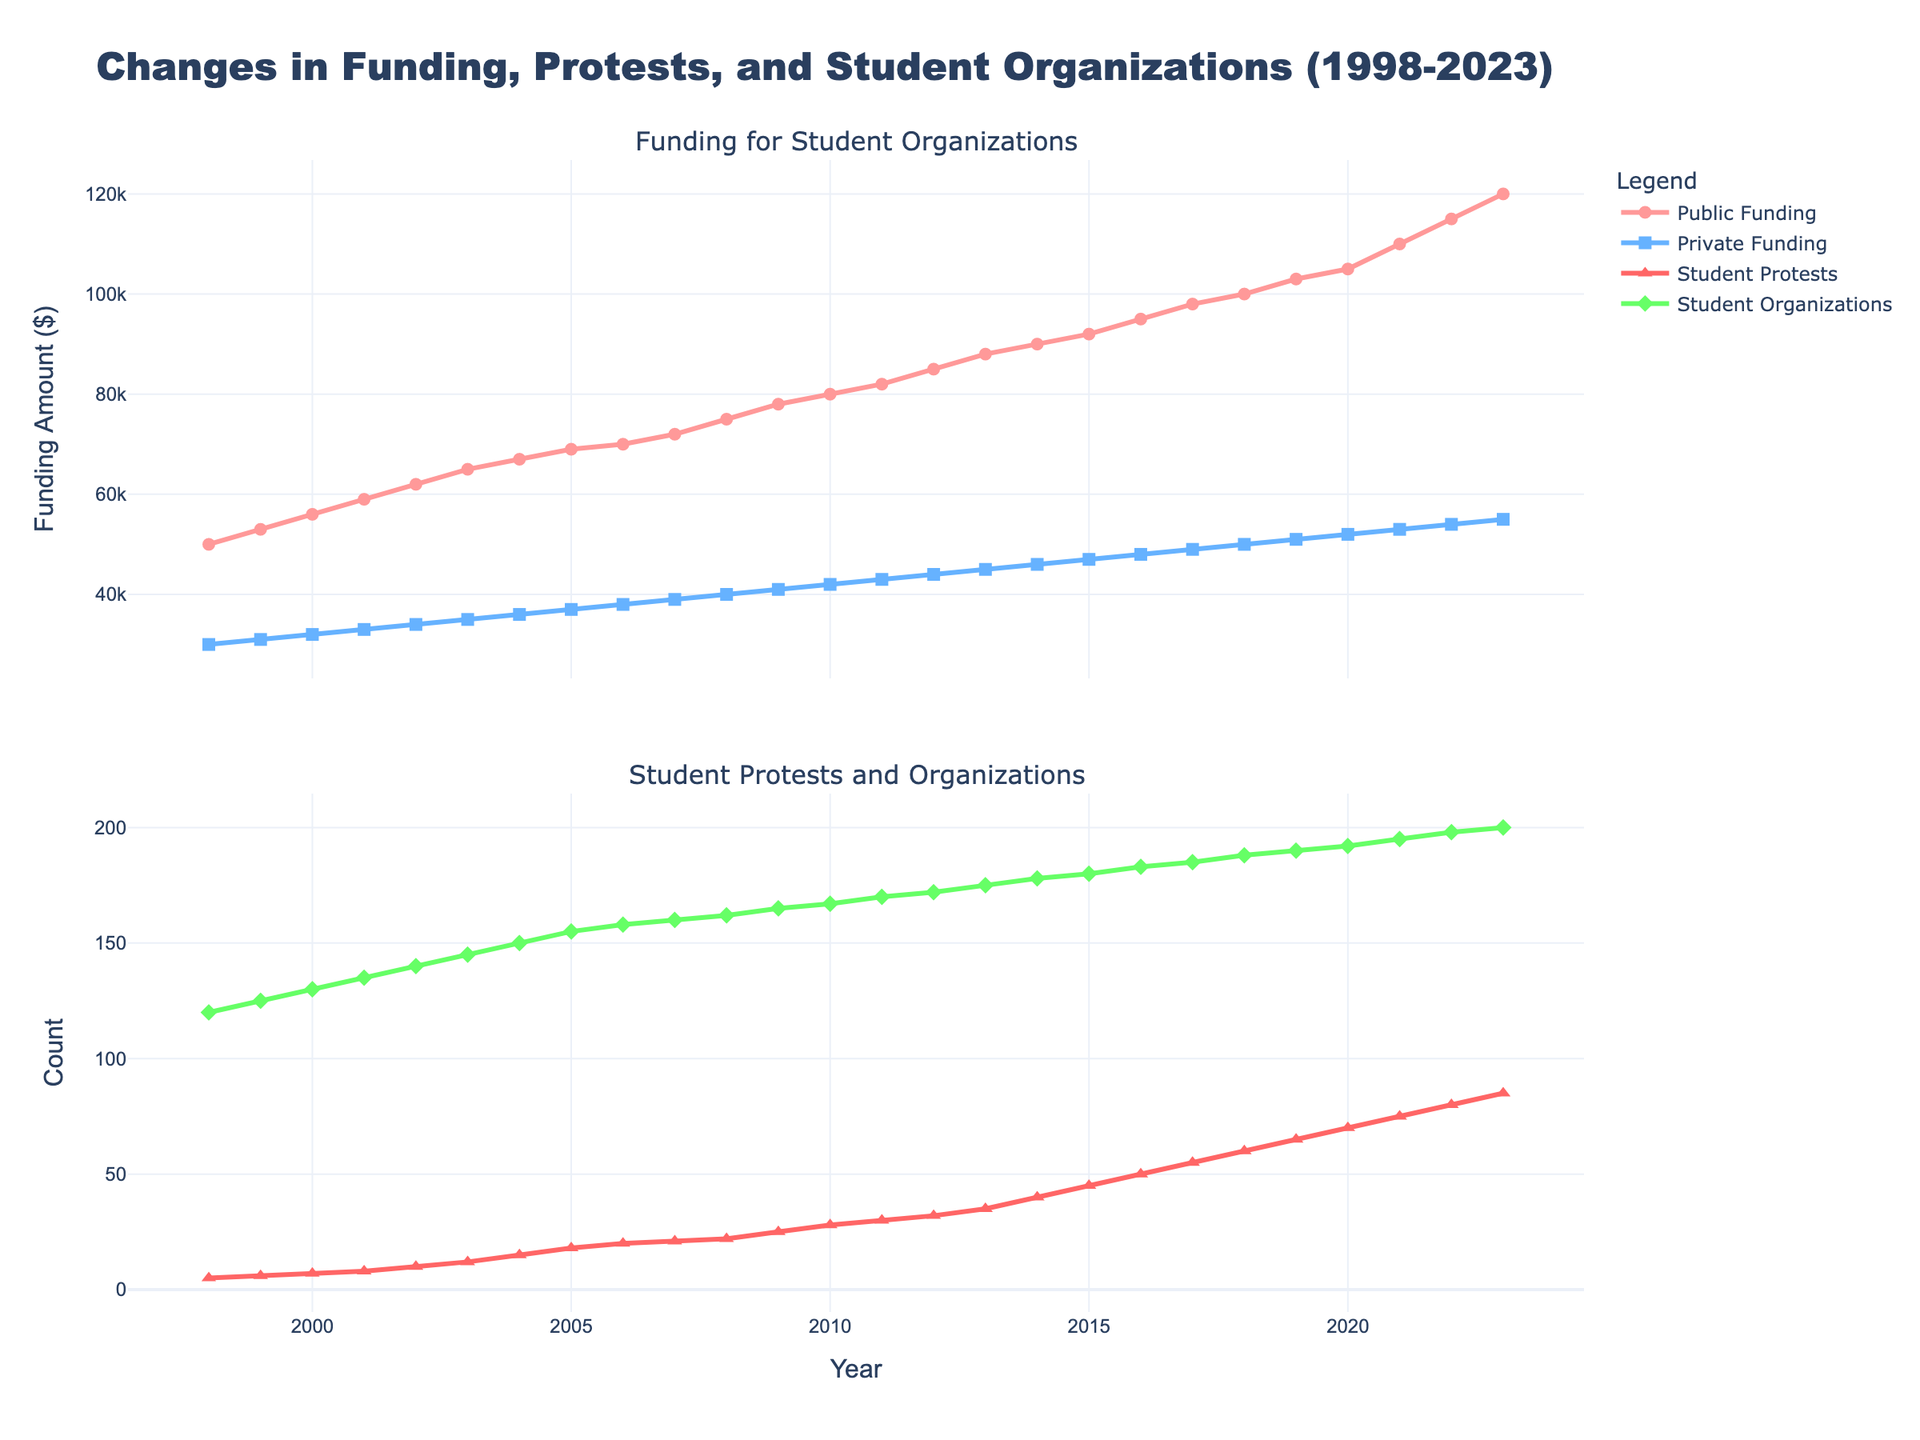How does public funding change over the years? The first subplot shows the change in public funding from 1998 to 2023. The line representing public funding consistently increases over the years, moving from $50,000 in 1998 to $120,000 in 2023.
Answer: Public funding consistently increases What is the title of the figure? The title of the figure is displayed at the top of the plot. It reads "Changes in Funding, Protests, and Student Organizations (1998-2023)."
Answer: Changes in Funding, Protests, and Student Organizations (1998-2023) What is the value of private funding in 2015 and how does it compare to public funding in the same year? By looking at the points marked for 2015 in the first subplot, private funding is at $47,000 while public funding is at $92,000. Public funding is almost double the private funding in 2015.
Answer: Private funding: $47,000, Public funding: $92,000 How many student organizations were there in 2000, and how did this number change by 2023? The second subplot shows the counts of student organizations. In 2000, there were 130 student organizations, and by 2023, this number increased to 200.
Answer: 2000: 130, 2023: 200 What trend can be observed in the number of student protests? Observing the second subplot, the number of student protests increases every year, starting from 5 in 1998 and reaching 85 in 2023.
Answer: Increasing trend Between which years did public funding see its largest annual increase? By checking the yearly increments shown in the lines and markers for public funding in the first subplot, the largest annual increase occurs between 2021 and 2022, moving from $110,000 to $115,000, a change of $5,000.
Answer: 2021-2022 How do private funding and public funding trends compare over the years? Both public and private funding show a consistent increasing trend from 1998 to 2023. However, public funding starts higher and grows at a faster rate compared to private funding.
Answer: Both increase, public grows faster What is the difference between the numbers of student protests in 1998 and 2023? In 1998, there were 5 student protests, and in 2023, there were 85. The difference is found by subtracting the smaller number from the larger number: 85 - 5 = 80.
Answer: 80 Between which consecutive years did private funding have the smallest increase? By checking the increments for each year in the first subplot, the smallest increase in private funding occurs between 2009 and 2010, moving from $41,000 to $42,000, an increment of $1,000.
Answer: 2009-2010 What is the average number of student organizations from 1998 to 2023? Sum the number of student organizations from 1998 (120) to 2023 (200), which totals 4,629. Then divide by the number of years (26): 4,629 / 26 ≈ 178.
Answer: 178 